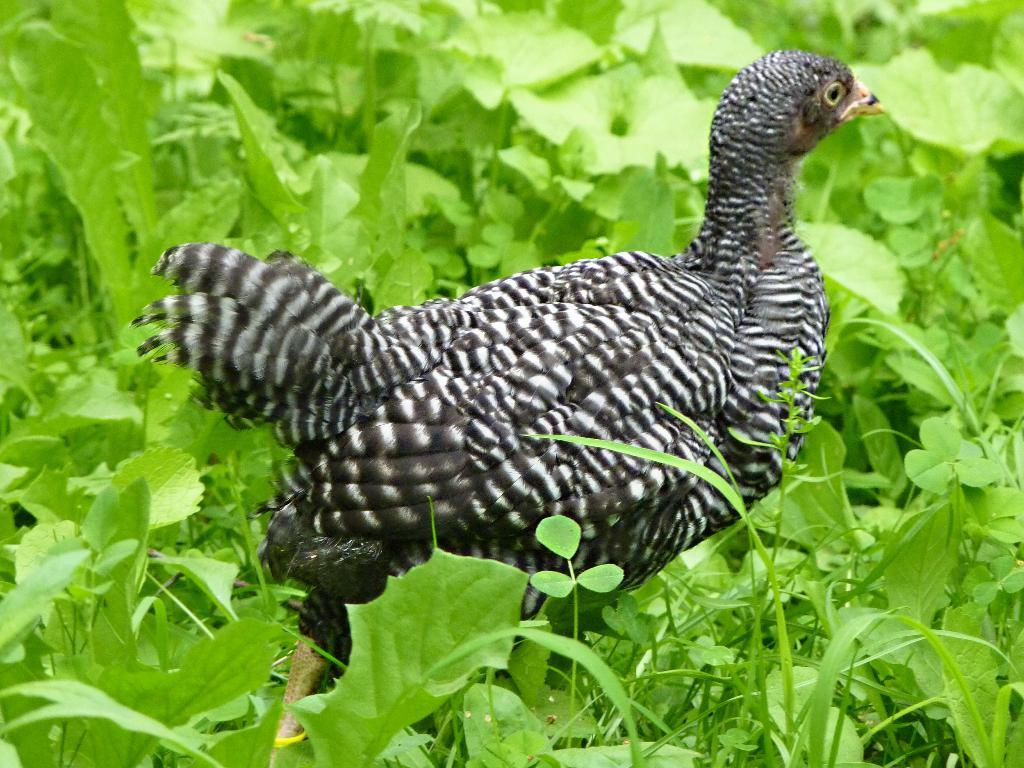What type of vegetation is present in the image? There are green-colored leaves in the image. What type of animal can be seen in the image? There is a black-colored bird in the image. Where is the bird located in the image? The bird is in the center of the image. What type of feast is the bird attending in the image? There is no indication of a feast or any gathering in the image; it simply features a bird in the center of the frame. 